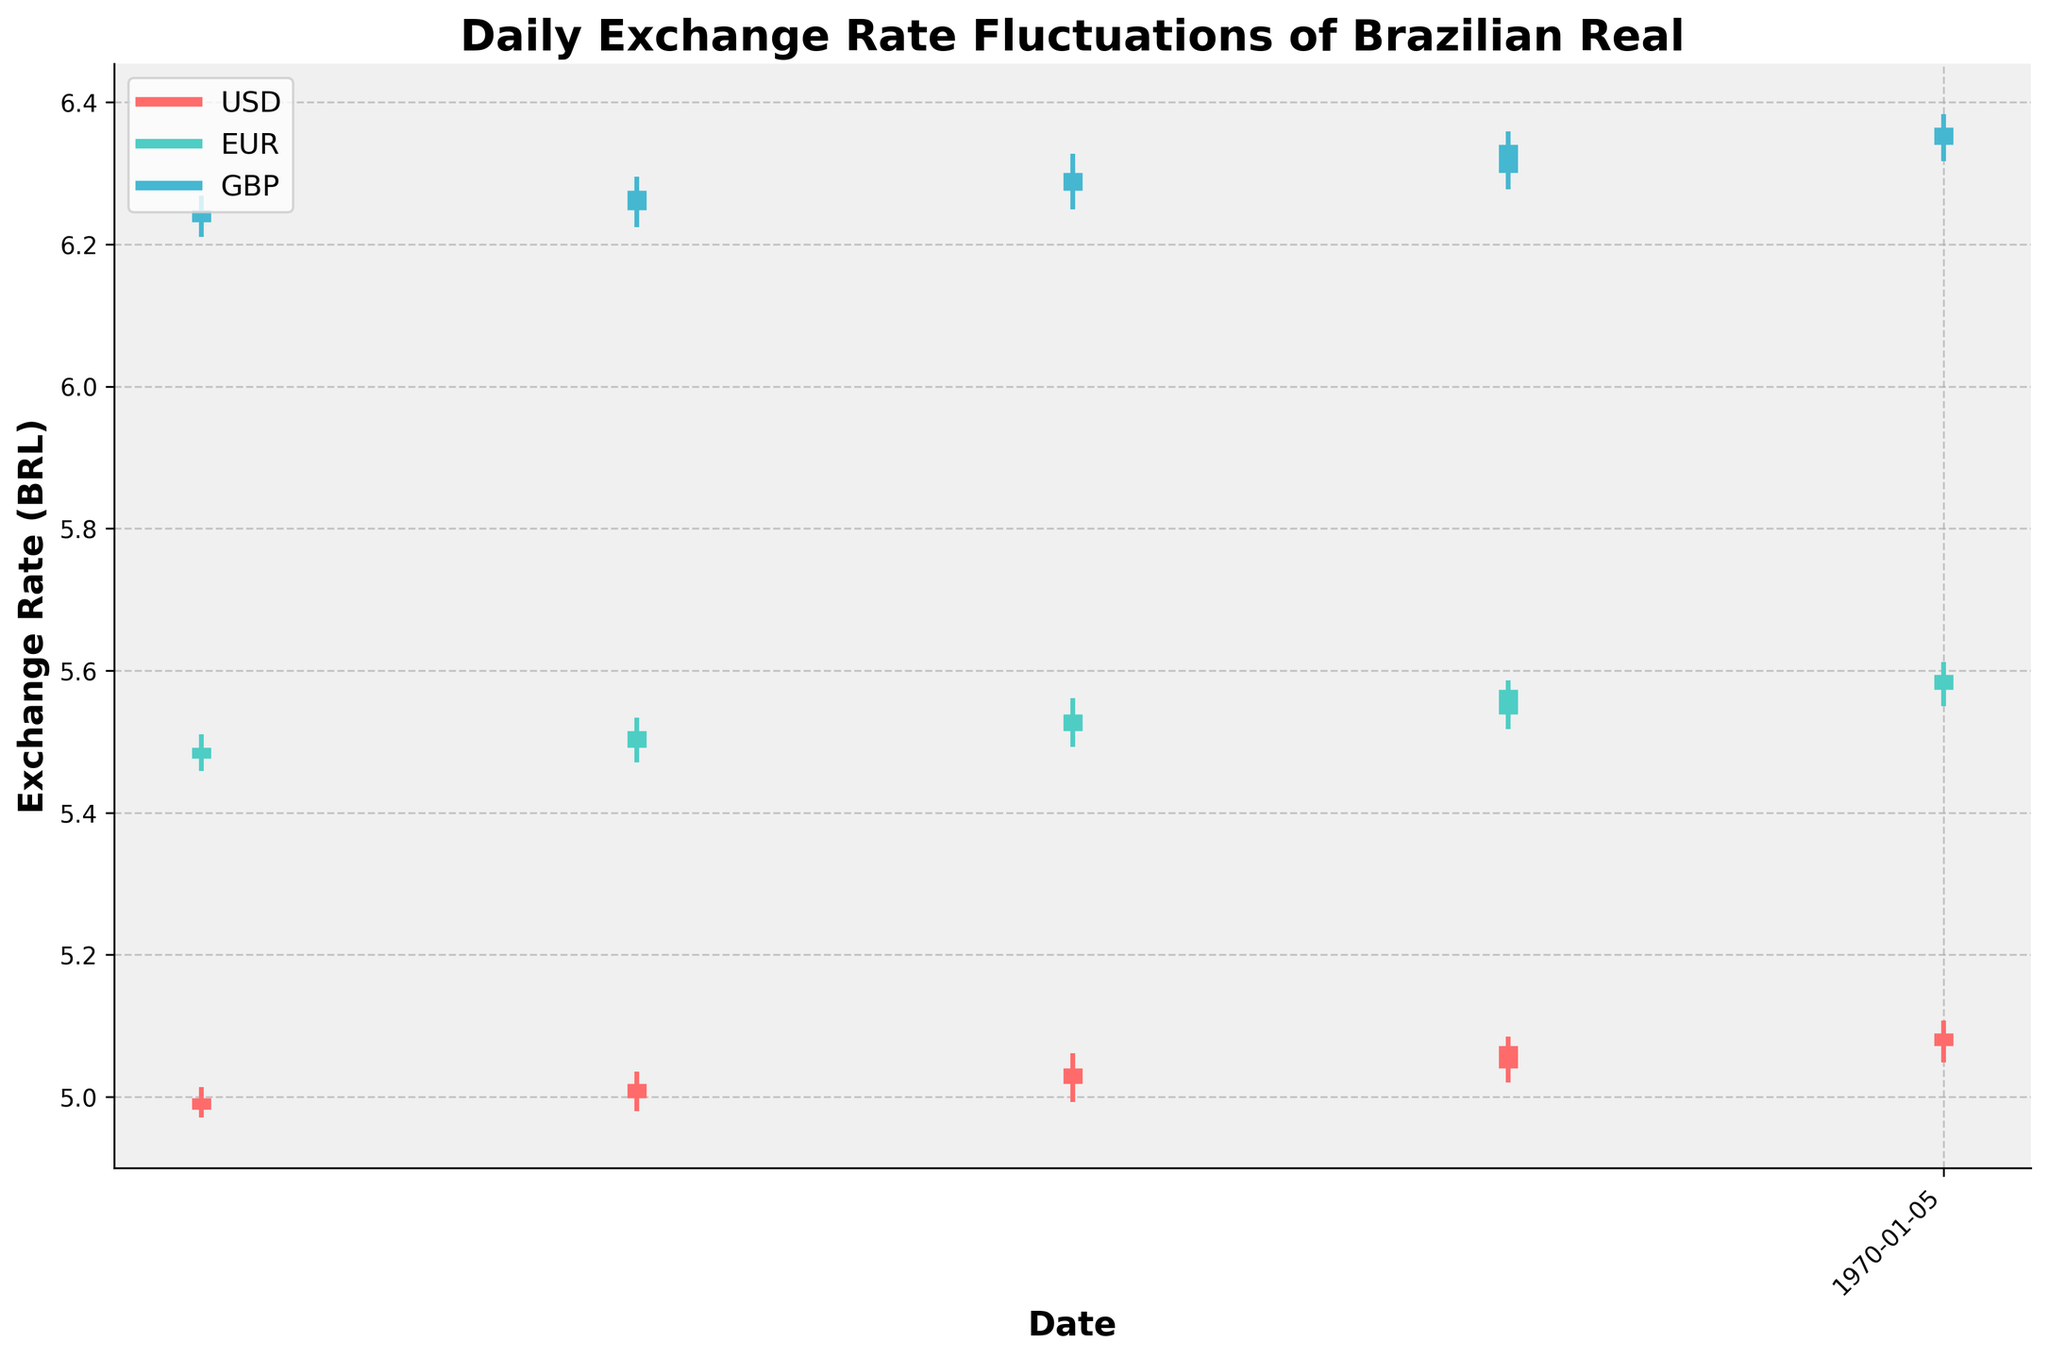What is the title of the figure? The title is usually placed at the top of the figure, and in this case, it is bold and larger than the other text on the plot.
Answer: Daily Exchange Rate Fluctuations of Brazilian Real Which currency experienced the highest exchange rate on May 15, 2023? By focusing on May 15, 2023, and comparing the 'High' values for each currency, the highest value appears in the GBP (6.3278).
Answer: GBP What is the lowest exchange rate recorded for USD throughout the month? From the OHLC data provided, the lowest value in the 'Low' column for USD is 4.9710, which occurred on May 1, 2023.
Answer: 4.9710 Between which dates did the EUR see the highest increase in its closing value? By comparing the 'Close' values for each week, the largest increase in closing value for EUR happened between May 22, 2023 (5.5734) and May 29, 2023 (5.5945) with an increase of 0.0211.
Answer: May 22, 2023 and May 29, 2023 How does the closing exchange rate of GBP on May 8, 2023 compare to its opening value on the same day? On May 8, 2023, the 'Open' value for GBP is 6.2487, and its 'Close' value is 6.2756. Since 6.2756 is higher than 6.2487, the closing rate is higher.
Answer: The closing rate is higher Which currency showed the most stable exchange rate, based on the range (High-Low), throughout the month? Stability can be assessed by comparing the smallest range (High-Low) for each currency. If we evaluate the ranges, USD generally has smaller differences between High and Low compared to EUR and GBP over the month.
Answer: USD What is the overall trend observed in the Brazilian Real exchange rate against USD over the month? By analyzing the 'Close' values over the weeks for USD (4.9987, 5.0189, 5.0402, 5.0723, 5.0901), we can see a general upward trend.
Answer: Upward trend Between USD and EUR, which currency had a higher 'Close' value on May 29, 2023? Comparing the 'Close' values on May 29, 2023, USD ends at 5.0901 while EUR ends at 5.5945. The EUR's 'Close' value is higher.
Answer: EUR Based on the visual representation, what was the opening and closing exchange rate for EUR on May 1, 2023? On May 1, 2023, the 'Open' rate for EUR is 5.4765, and the 'Close' rate is 5.4918. Both values are shown in the OHLC chart for the specific date.
Answer: Open: 5.4765, Close: 5.4918 How does the exchange rate fluctuation for USD compare to GBP over the month? By examining the difference (High-Low), USD fluctuations are generally smaller compared to GBP, indicating more stability in the USD exchange rate over the month.
Answer: USD is more stable than GBP 